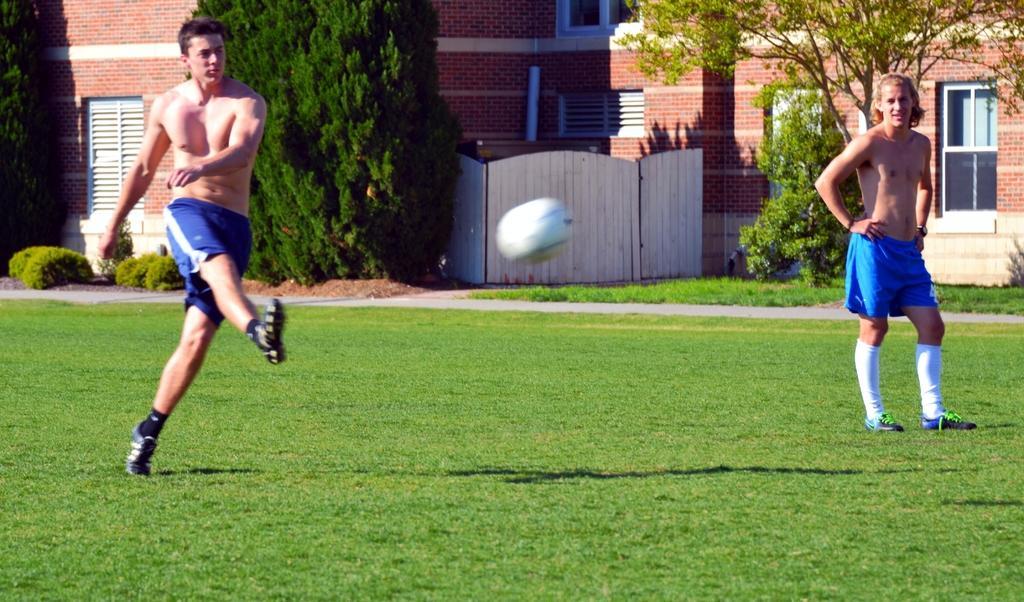How would you summarize this image in a sentence or two? In the image there are two men on the grass surface, the first man hit a ball with his leg and the ball is flying in the air, in the background there are trees and behind the trees there is a building. 